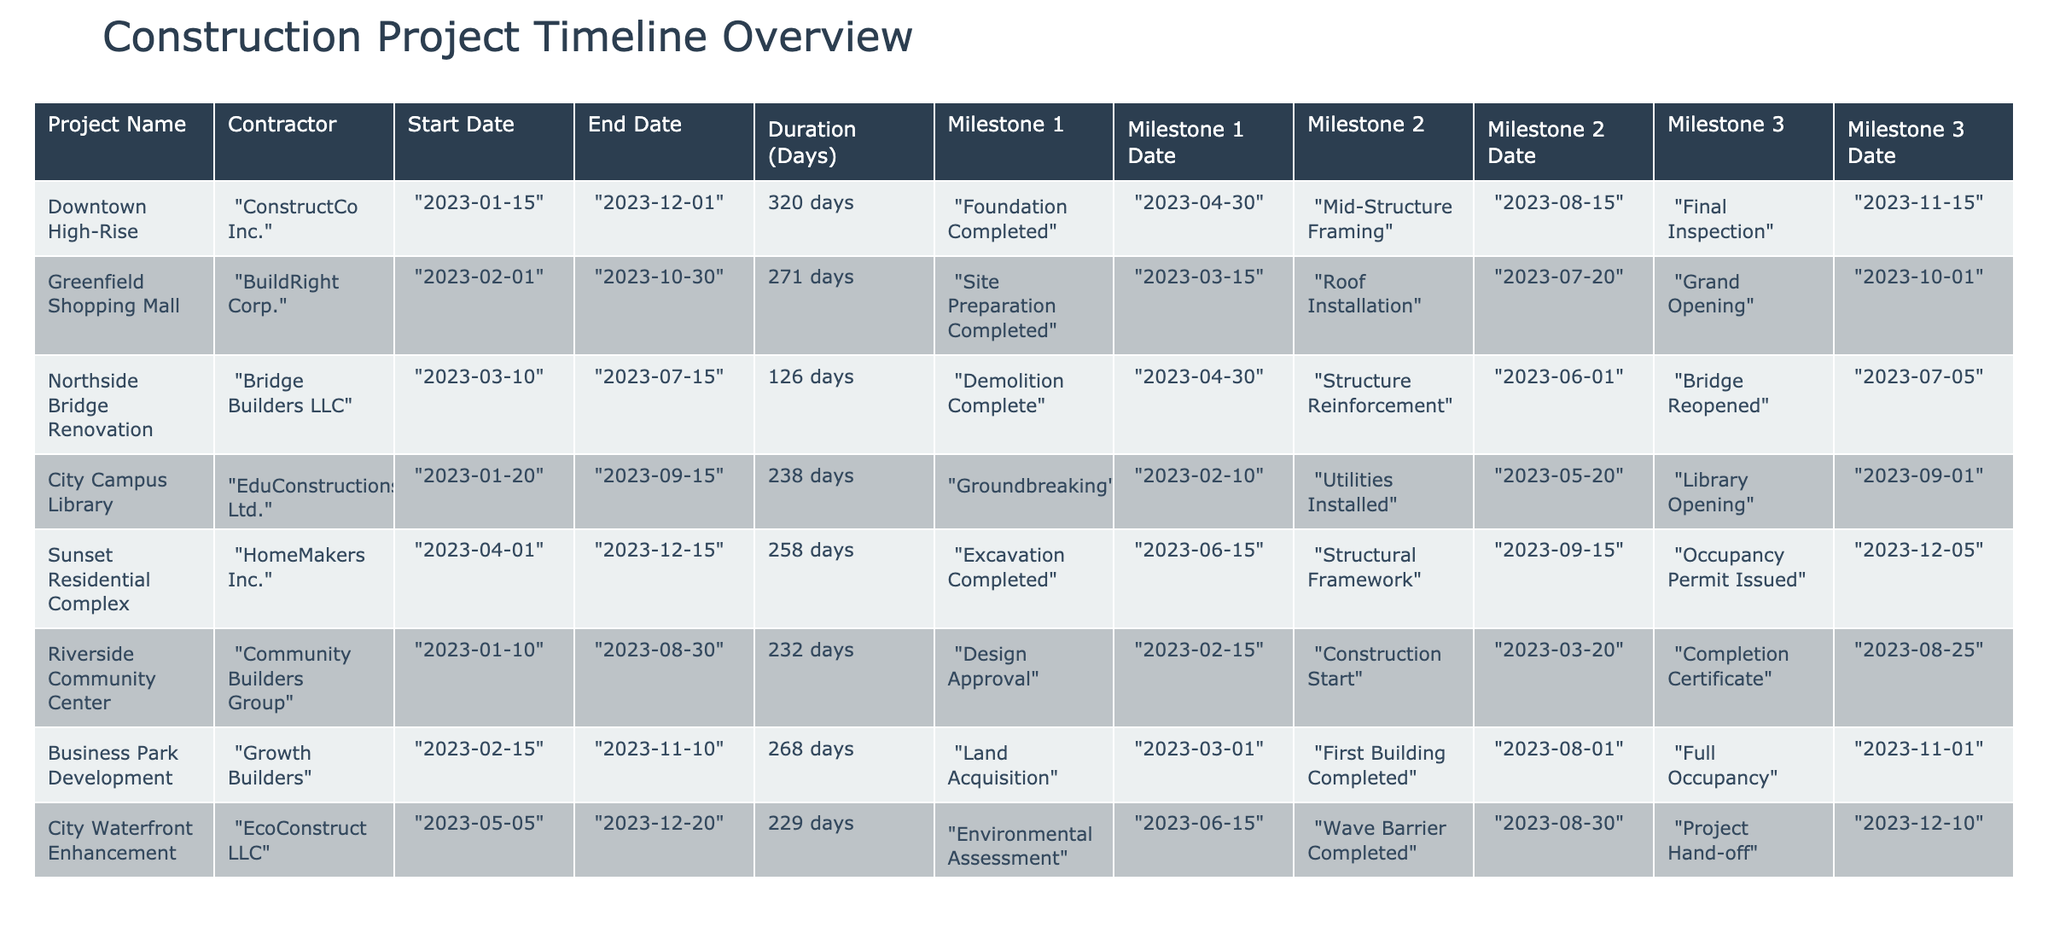What is the duration of the "Greenfield Shopping Mall" project? The "Greenfield Shopping Mall" project has a duration of 271 days according to the table.
Answer: 271 days Which project had its "Foundation Completed" milestone on April 30, 2023? The project "Downtown High-Rise" achieved the "Foundation Completed" milestone on April 30, 2023.
Answer: Downtown High-Rise How many milestones did the "Riverside Community Center" project complete? The "Riverside Community Center" project completed three milestones: "Design Approval," "Construction Start," and "Completion Certificate."
Answer: Three Is the "City Campus Library" project duration shorter than that of "Northside Bridge Renovation"? The duration for the "City Campus Library" is 238 days, while "Northside Bridge Renovation" is 126 days, so the answer is yes, as 238 is greater than 126.
Answer: Yes What is the difference in duration between the "Sunset Residential Complex" and "Business Park Development" projects? The "Sunset Residential Complex" has a duration of 258 days and "Business Park Development" has 268 days. The difference is 268 - 258 = 10 days.
Answer: 10 days Which project will have its Grand Opening before the "Occupancy Permit Issued"? The "Greenfield Shopping Mall" has its Grand Opening on October 1, 2023, while the "Sunset Residential Complex" has its Occupancy Permit Issued on December 5, 2023. Since October comes before December, the answer is the "Greenfield Shopping Mall."
Answer: Greenfield Shopping Mall What is the earliest milestone completion date across all projects? The earliest milestone completion date is February 10, 2023, for the "Groundbreaking" milestone of the "City Campus Library." This date is earlier than any other milestone date listed in the table.
Answer: February 10, 2023 How many projects have their end dates in December 2023? There are three projects ending in December 2023: "Downtown High-Rise," "Sunset Residential Complex," and "City Waterfront Enhancement."
Answer: Three Is "ConstructCo Inc." the contractor for "Northside Bridge Renovation"? No, the contractor for "Northside Bridge Renovation" is "Bridge Builders LLC," not "ConstructCo Inc."
Answer: No 